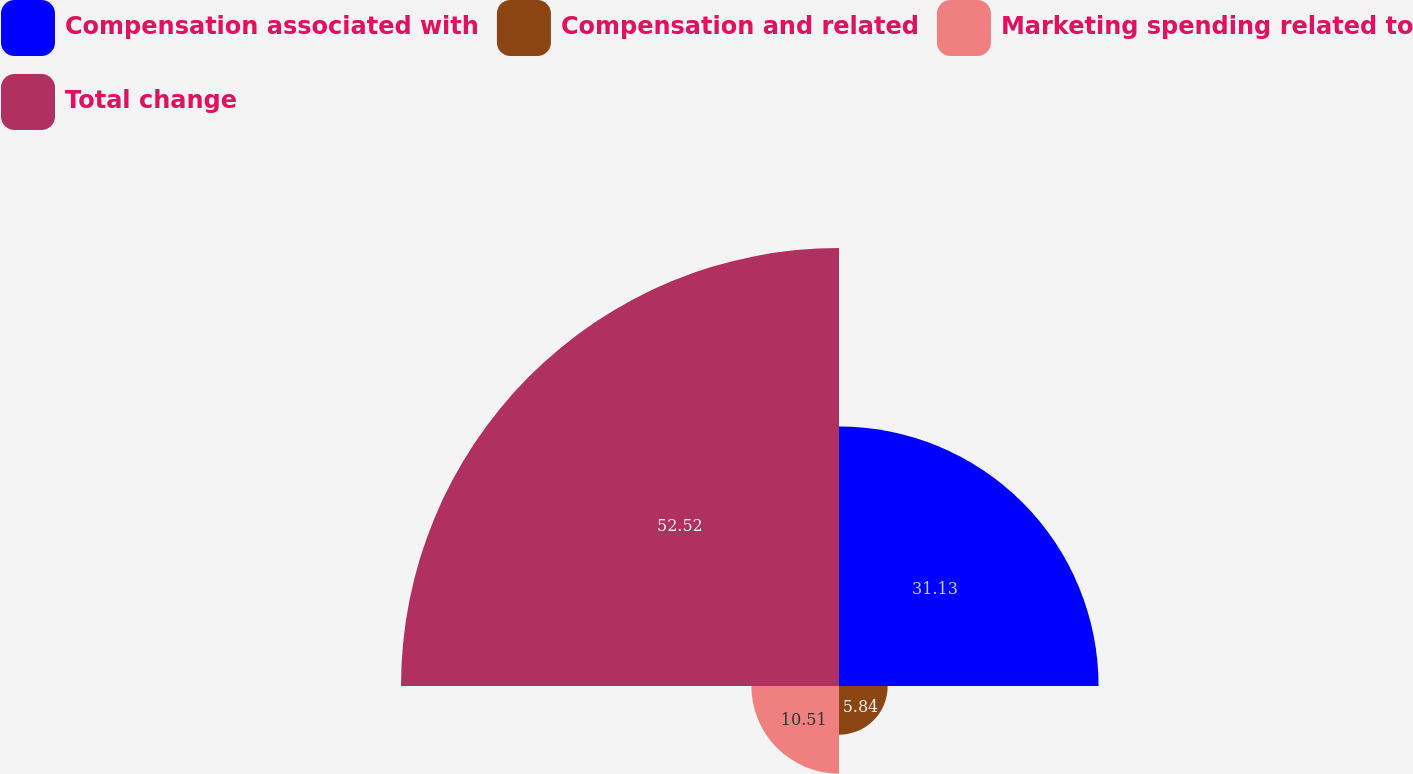<chart> <loc_0><loc_0><loc_500><loc_500><pie_chart><fcel>Compensation associated with<fcel>Compensation and related<fcel>Marketing spending related to<fcel>Total change<nl><fcel>31.13%<fcel>5.84%<fcel>10.51%<fcel>52.53%<nl></chart> 